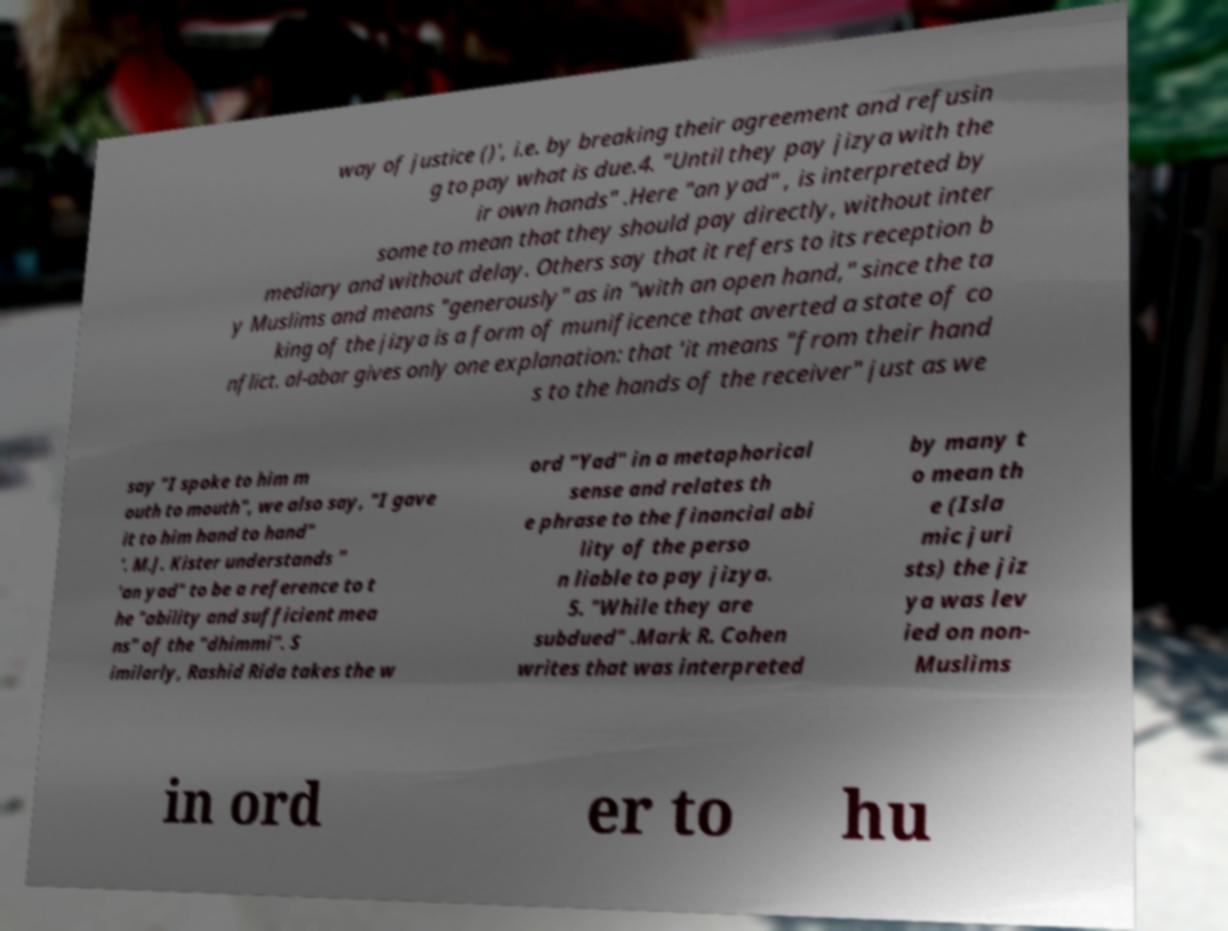What messages or text are displayed in this image? I need them in a readable, typed format. way of justice ()', i.e. by breaking their agreement and refusin g to pay what is due.4. "Until they pay jizya with the ir own hands" .Here "an yad" , is interpreted by some to mean that they should pay directly, without inter mediary and without delay. Others say that it refers to its reception b y Muslims and means "generously" as in "with an open hand," since the ta king of the jizya is a form of munificence that averted a state of co nflict. al-abar gives only one explanation: that 'it means "from their hand s to the hands of the receiver" just as we say "I spoke to him m outh to mouth", we also say, "I gave it to him hand to hand" '. M.J. Kister understands " 'an yad" to be a reference to t he "ability and sufficient mea ns" of the "dhimmi". S imilarly, Rashid Rida takes the w ord "Yad" in a metaphorical sense and relates th e phrase to the financial abi lity of the perso n liable to pay jizya. 5. "While they are subdued" .Mark R. Cohen writes that was interpreted by many t o mean th e (Isla mic juri sts) the jiz ya was lev ied on non- Muslims in ord er to hu 